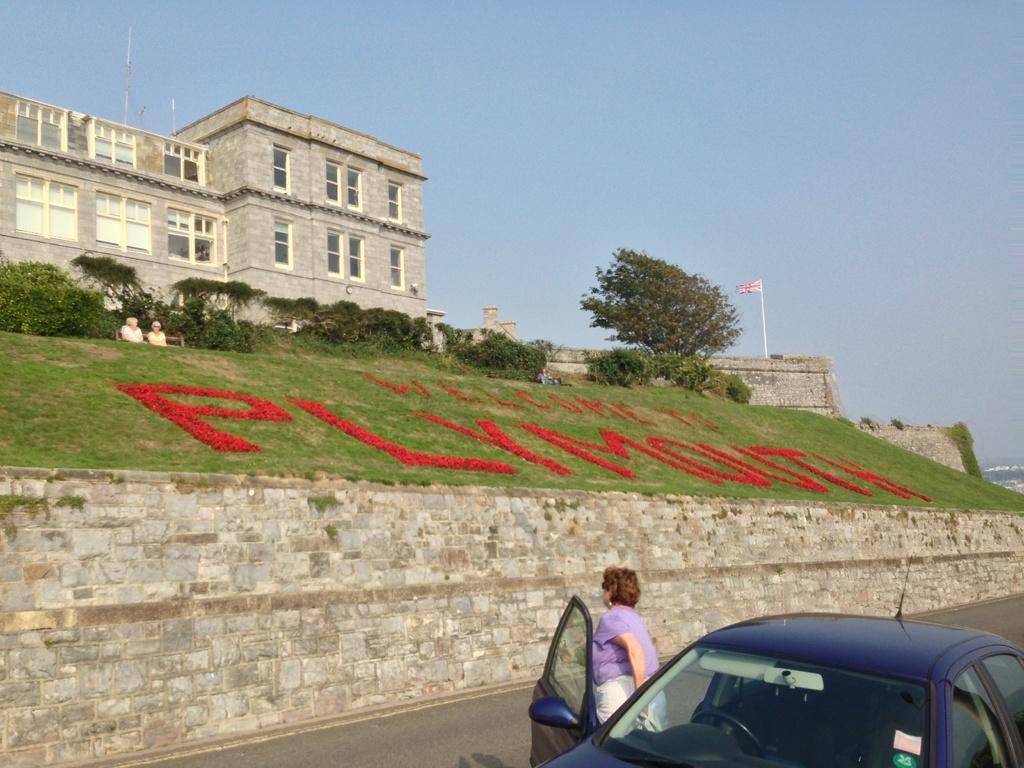Can you describe this image briefly? In the foreground of this image, there is a vehicle on the road and a woman near the door of that vehicle. In the middle, there is some text on the grass, trees, a building, flag, sky and few people sitting on the benches. 